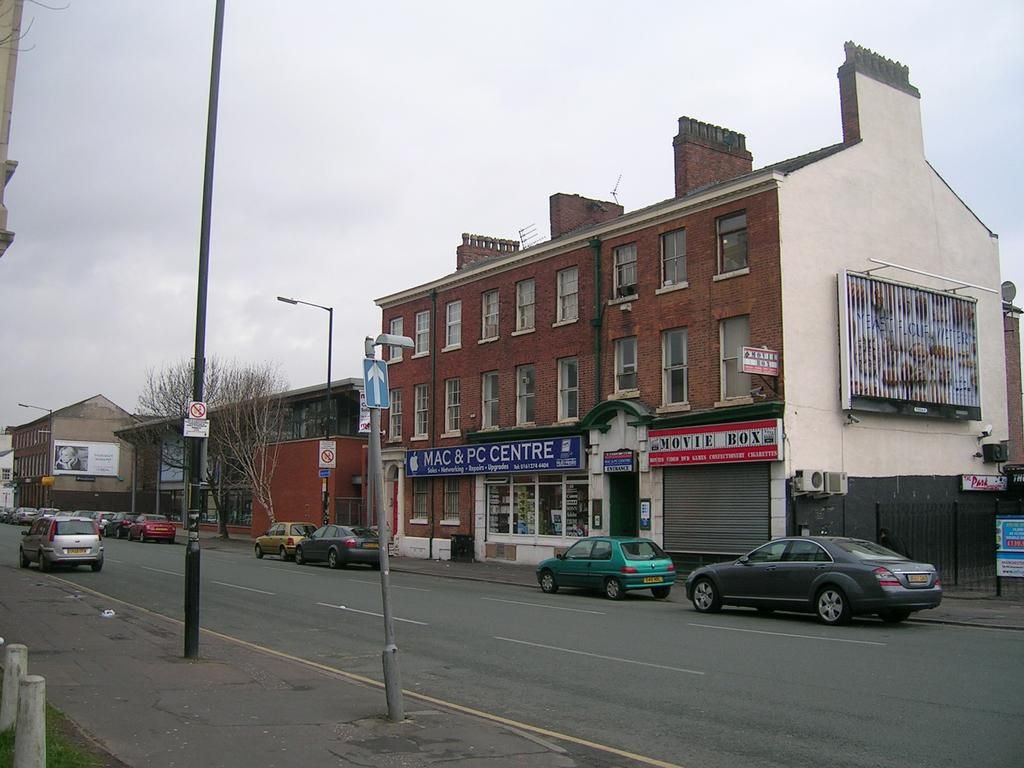What is the main subject of the image? The image depicts a road. What is happening on the road? There are vehicles moving on the road. What can be seen on the right side of the image? There is a building on the right side of the image. What type of establishment might be located at the bottom of the image? There appears to be a store at the bottom of the image. How would you describe the weather based on the image? The sky is cloudy in the image. What flavor of sail can be seen on the vehicles in the image? There are no sails present in the image, and vehicles do not have flavors. 